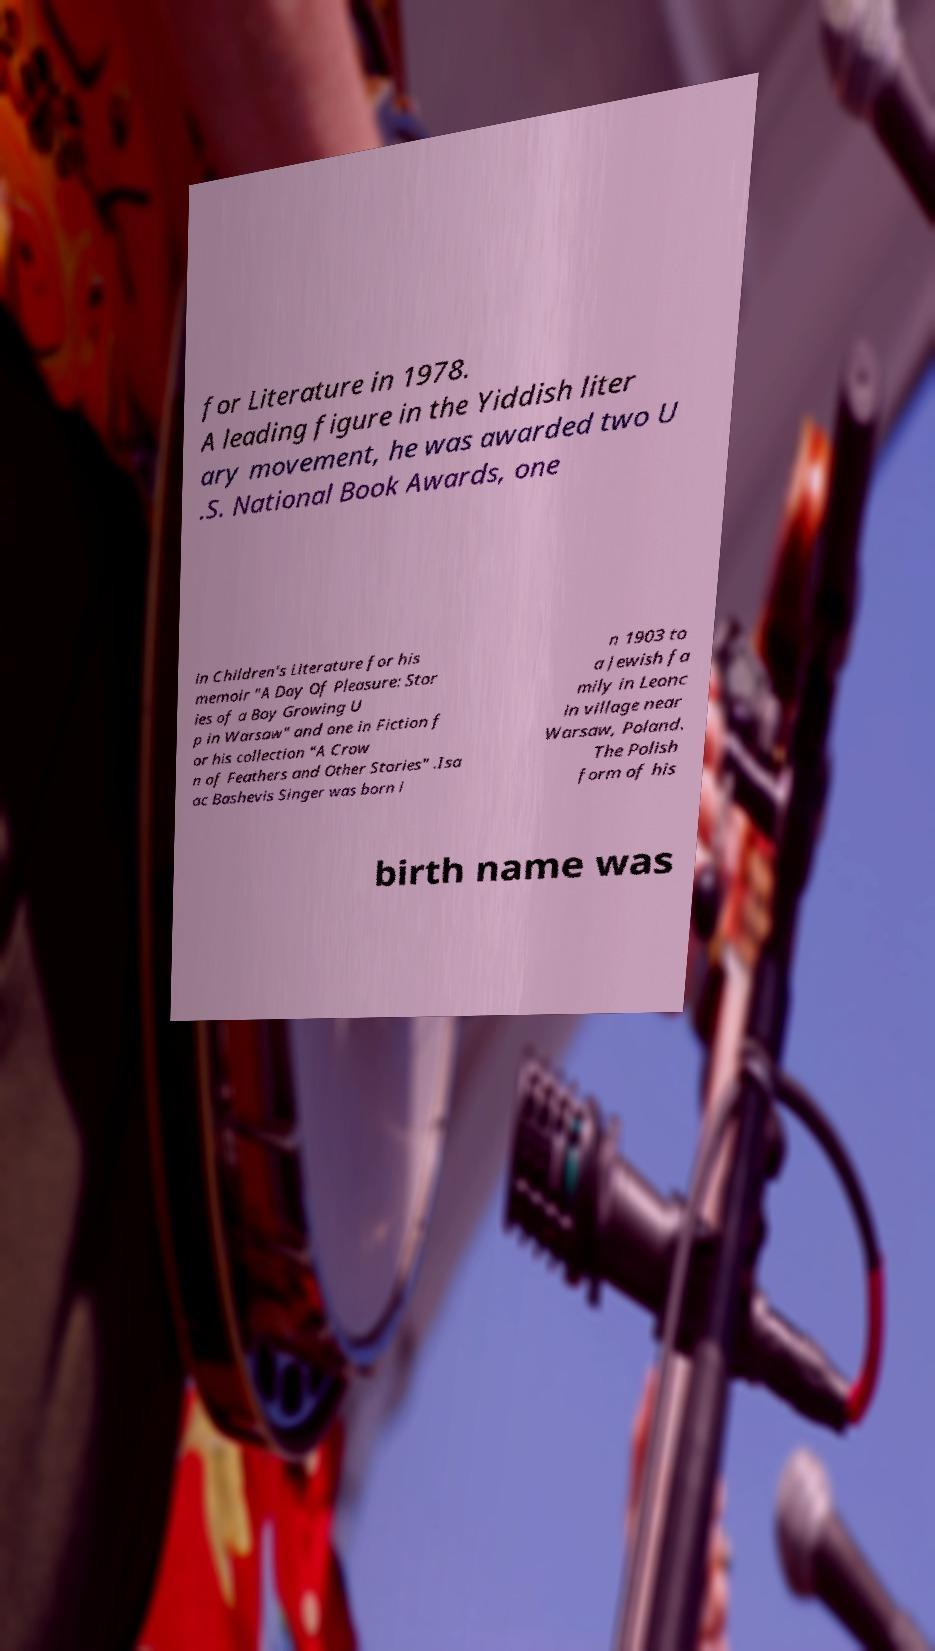There's text embedded in this image that I need extracted. Can you transcribe it verbatim? for Literature in 1978. A leading figure in the Yiddish liter ary movement, he was awarded two U .S. National Book Awards, one in Children's Literature for his memoir "A Day Of Pleasure: Stor ies of a Boy Growing U p in Warsaw" and one in Fiction f or his collection "A Crow n of Feathers and Other Stories" .Isa ac Bashevis Singer was born i n 1903 to a Jewish fa mily in Leonc in village near Warsaw, Poland. The Polish form of his birth name was 